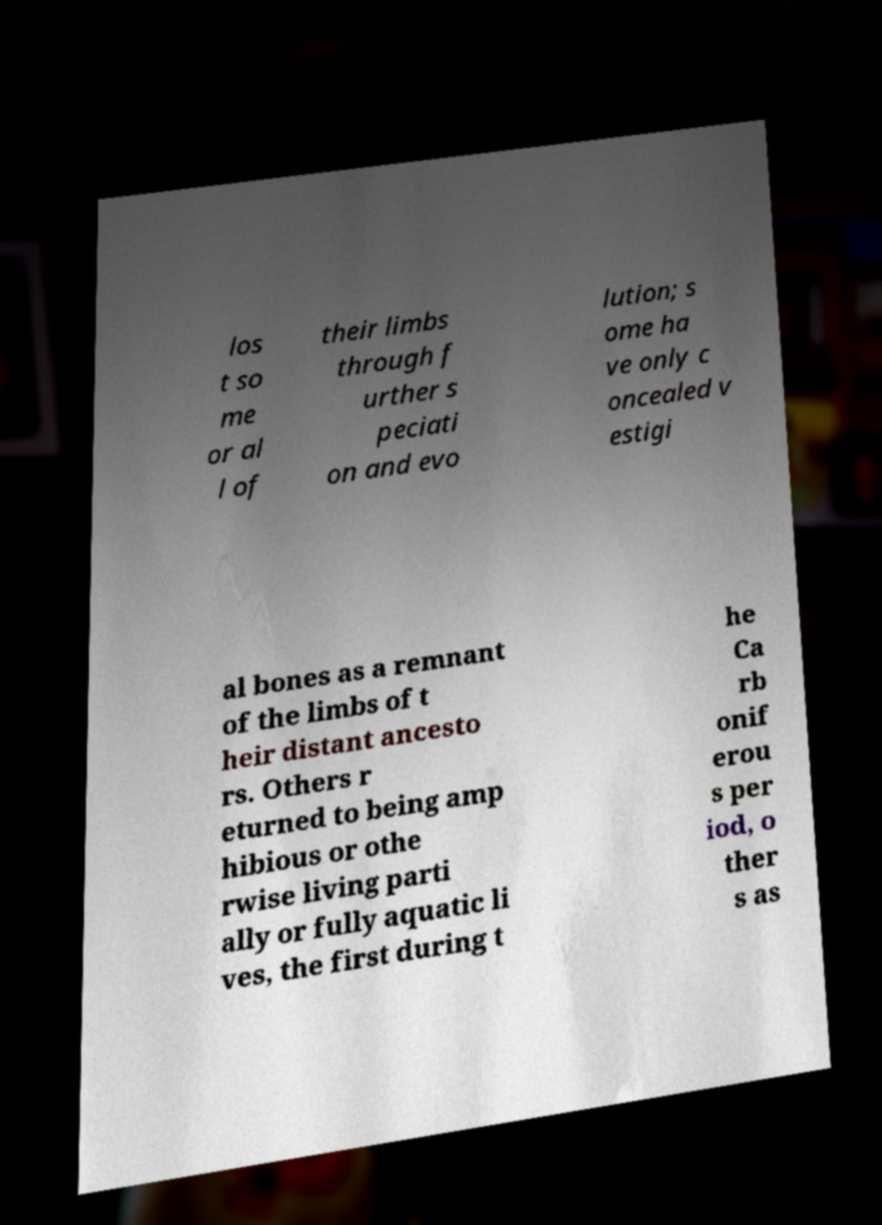Can you read and provide the text displayed in the image?This photo seems to have some interesting text. Can you extract and type it out for me? los t so me or al l of their limbs through f urther s peciati on and evo lution; s ome ha ve only c oncealed v estigi al bones as a remnant of the limbs of t heir distant ancesto rs. Others r eturned to being amp hibious or othe rwise living parti ally or fully aquatic li ves, the first during t he Ca rb onif erou s per iod, o ther s as 